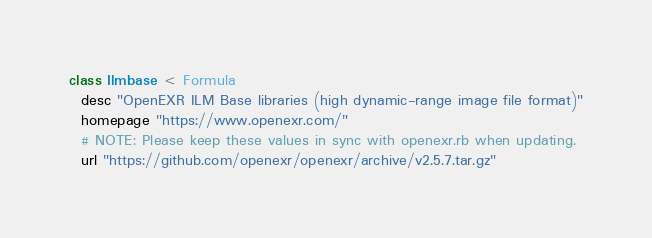Convert code to text. <code><loc_0><loc_0><loc_500><loc_500><_Ruby_>class Ilmbase < Formula
  desc "OpenEXR ILM Base libraries (high dynamic-range image file format)"
  homepage "https://www.openexr.com/"
  # NOTE: Please keep these values in sync with openexr.rb when updating.
  url "https://github.com/openexr/openexr/archive/v2.5.7.tar.gz"</code> 